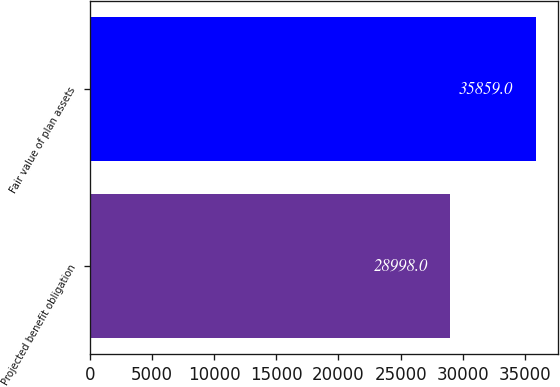<chart> <loc_0><loc_0><loc_500><loc_500><bar_chart><fcel>Projected benefit obligation<fcel>Fair value of plan assets<nl><fcel>28998<fcel>35859<nl></chart> 